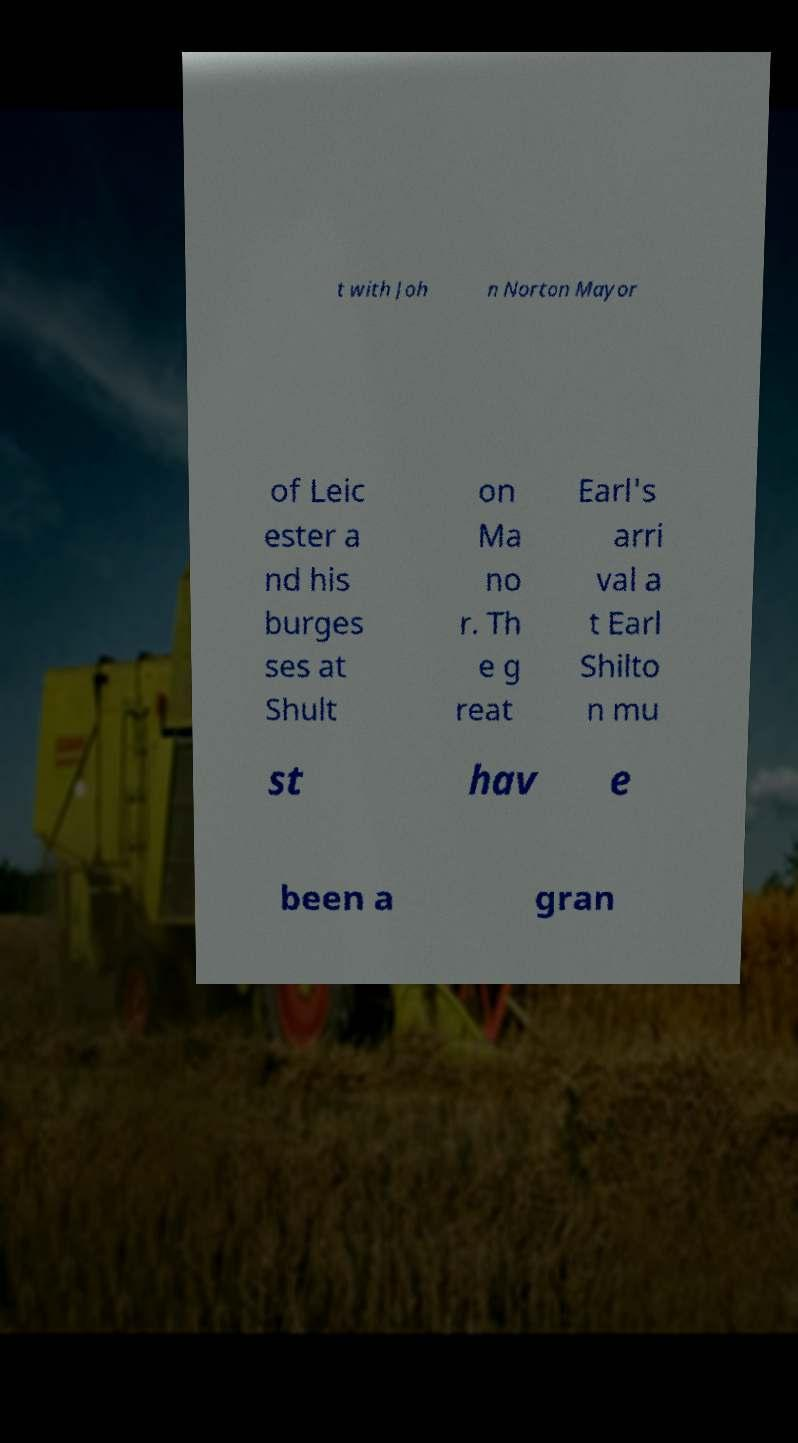Can you read and provide the text displayed in the image?This photo seems to have some interesting text. Can you extract and type it out for me? t with Joh n Norton Mayor of Leic ester a nd his burges ses at Shult on Ma no r. Th e g reat Earl's arri val a t Earl Shilto n mu st hav e been a gran 